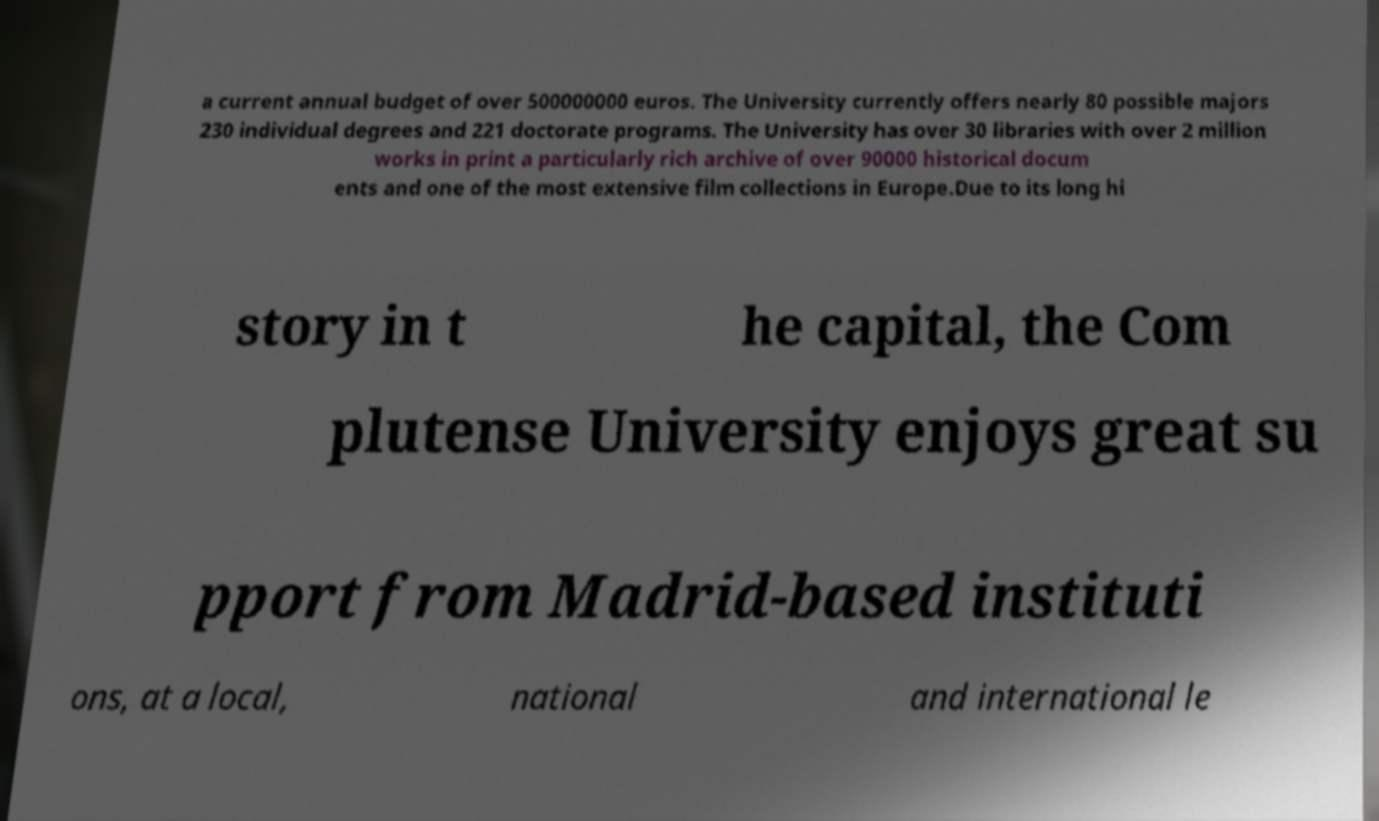For documentation purposes, I need the text within this image transcribed. Could you provide that? a current annual budget of over 500000000 euros. The University currently offers nearly 80 possible majors 230 individual degrees and 221 doctorate programs. The University has over 30 libraries with over 2 million works in print a particularly rich archive of over 90000 historical docum ents and one of the most extensive film collections in Europe.Due to its long hi story in t he capital, the Com plutense University enjoys great su pport from Madrid-based instituti ons, at a local, national and international le 